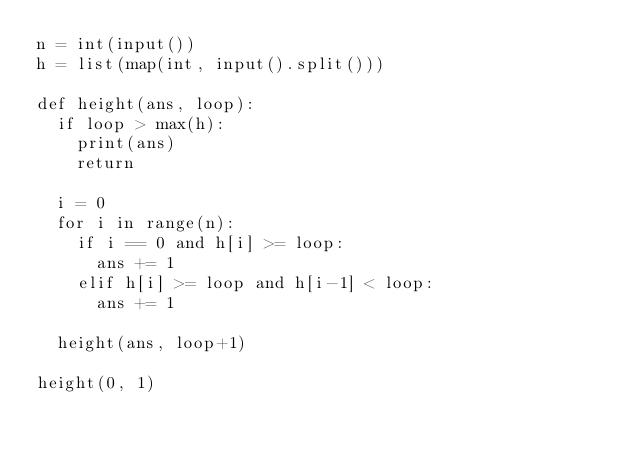Convert code to text. <code><loc_0><loc_0><loc_500><loc_500><_Python_>n = int(input())
h = list(map(int, input().split()))

def height(ans, loop):
  if loop > max(h):
    print(ans)
    return
  
  i = 0
  for i in range(n):
    if i == 0 and h[i] >= loop:
      ans += 1
    elif h[i] >= loop and h[i-1] < loop:
      ans += 1
      
  height(ans, loop+1)
  
height(0, 1)</code> 